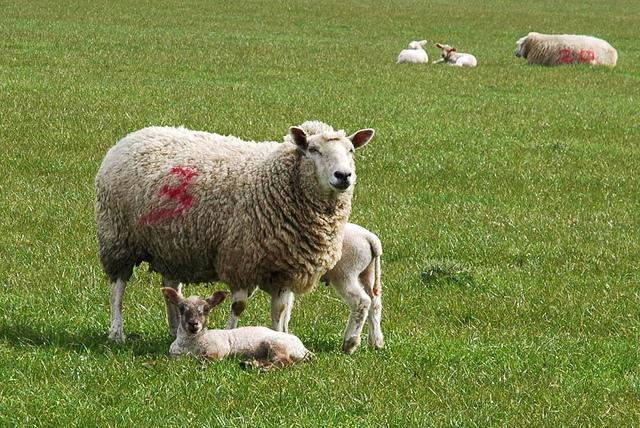What material do these animals provide for clothing? Please explain your reasoning. wool. The sheep can be sheared for their coats to make wool. 